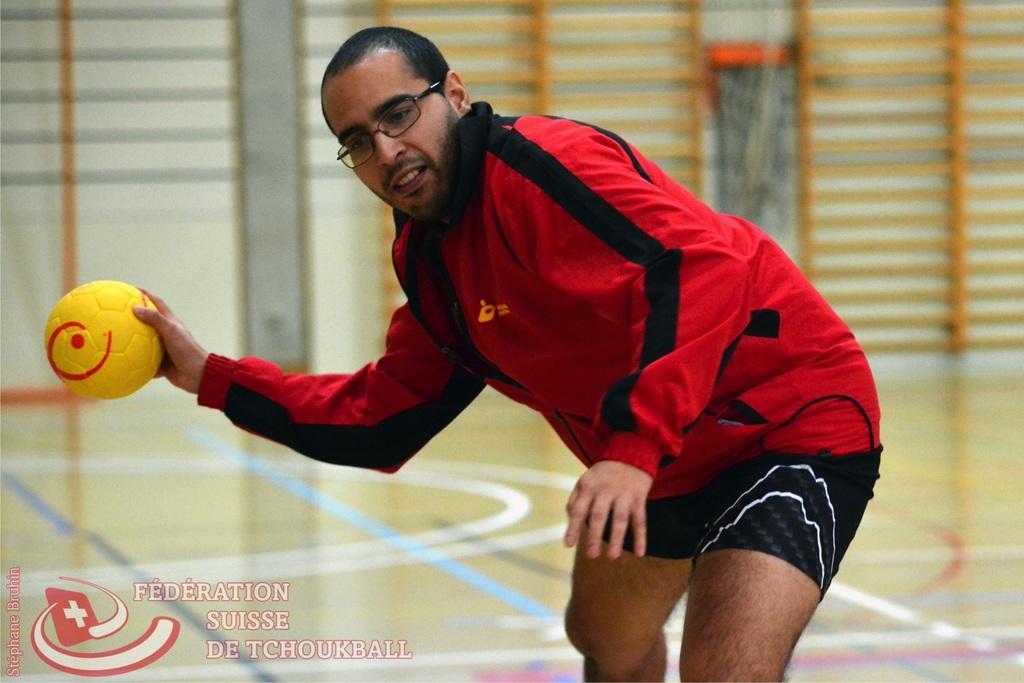Can you describe this image briefly? In this image there is a man standing and holding a ball in his hand. 